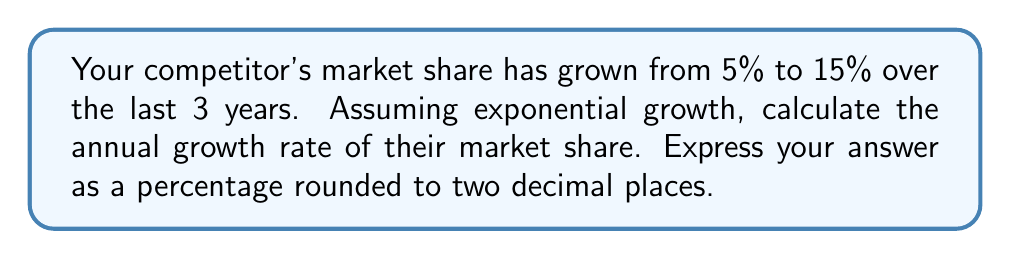What is the answer to this math problem? To solve this problem, we'll use the exponential growth formula:

$$A = P(1 + r)^t$$

Where:
$A$ = Final amount (15%)
$P$ = Initial amount (5%)
$r$ = Annual growth rate (what we're solving for)
$t$ = Time period (3 years)

1. Substitute the known values into the formula:
   $$15 = 5(1 + r)^3$$

2. Divide both sides by 5:
   $$3 = (1 + r)^3$$

3. Take the cube root of both sides:
   $$\sqrt[3]{3} = 1 + r$$

4. Subtract 1 from both sides:
   $$\sqrt[3]{3} - 1 = r$$

5. Calculate the value:
   $$r \approx 1.4422 - 1 = 0.4422$$

6. Convert to a percentage:
   $$0.4422 \times 100 = 44.22\%$$

Therefore, the annual growth rate is approximately 44.22%.
Answer: 44.22% 